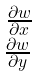<formula> <loc_0><loc_0><loc_500><loc_500>\begin{smallmatrix} \, \frac { \partial w } { \partial x } \\ \frac { \partial w } { \partial y } \end{smallmatrix}</formula> 